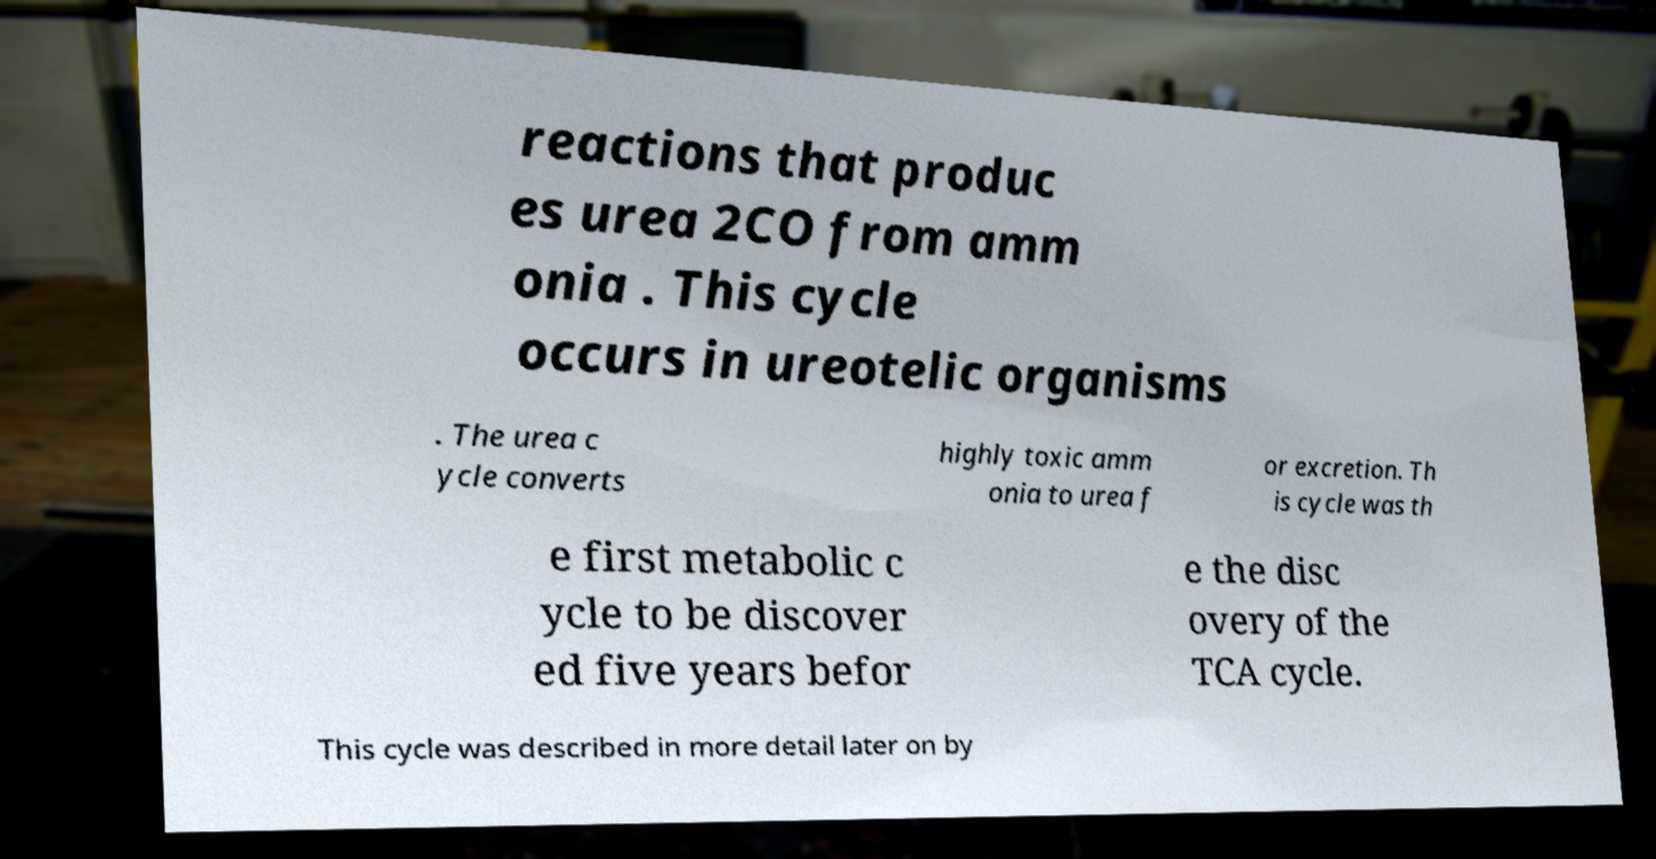Can you read and provide the text displayed in the image?This photo seems to have some interesting text. Can you extract and type it out for me? reactions that produc es urea 2CO from amm onia . This cycle occurs in ureotelic organisms . The urea c ycle converts highly toxic amm onia to urea f or excretion. Th is cycle was th e first metabolic c ycle to be discover ed five years befor e the disc overy of the TCA cycle. This cycle was described in more detail later on by 